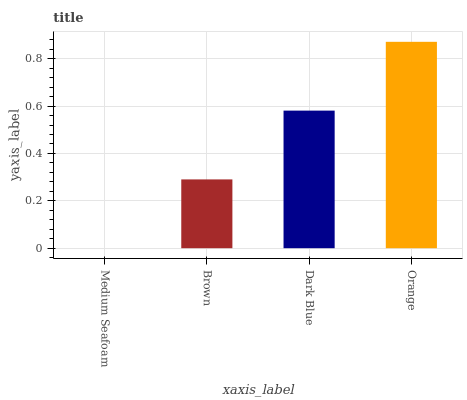Is Medium Seafoam the minimum?
Answer yes or no. Yes. Is Orange the maximum?
Answer yes or no. Yes. Is Brown the minimum?
Answer yes or no. No. Is Brown the maximum?
Answer yes or no. No. Is Brown greater than Medium Seafoam?
Answer yes or no. Yes. Is Medium Seafoam less than Brown?
Answer yes or no. Yes. Is Medium Seafoam greater than Brown?
Answer yes or no. No. Is Brown less than Medium Seafoam?
Answer yes or no. No. Is Dark Blue the high median?
Answer yes or no. Yes. Is Brown the low median?
Answer yes or no. Yes. Is Orange the high median?
Answer yes or no. No. Is Dark Blue the low median?
Answer yes or no. No. 